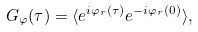<formula> <loc_0><loc_0><loc_500><loc_500>G _ { \varphi } ( \tau ) = \langle e ^ { i \varphi _ { r } ( \tau ) } e ^ { - i \varphi _ { r } ( 0 ) } \rangle ,</formula> 